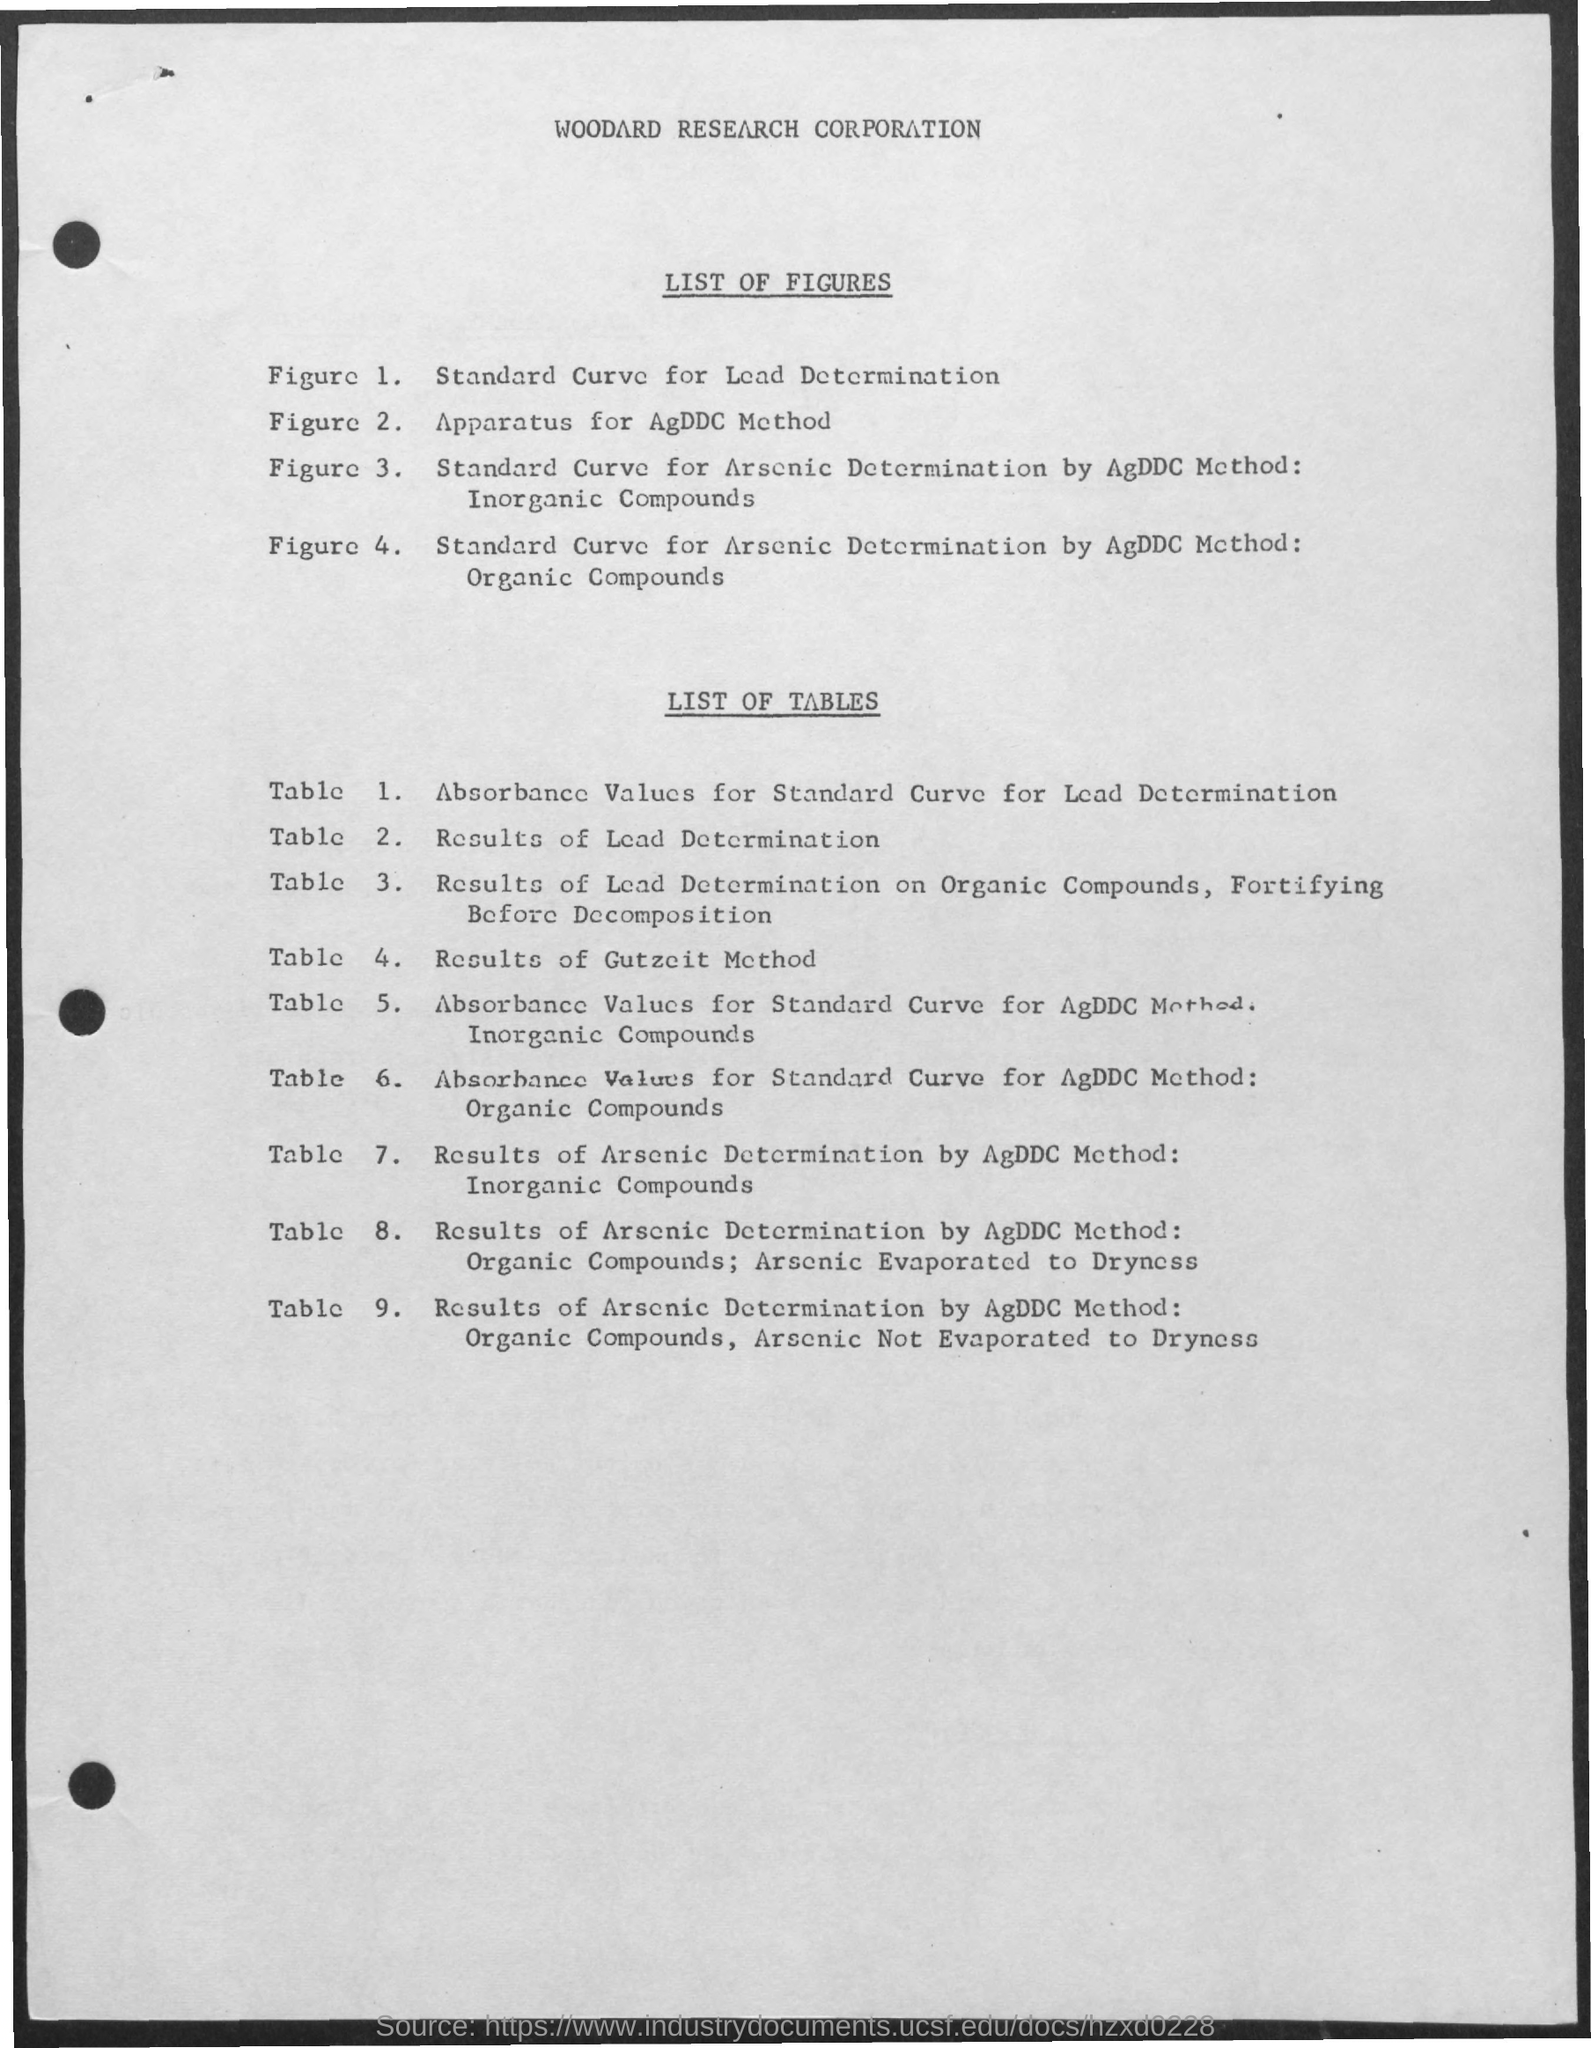What is the first title in the document?
Your answer should be very brief. Woodard Research Corporation. What is the second title in the document?
Provide a succinct answer. List of Figures. What is the third title in the document?
Keep it short and to the point. List of tables. 